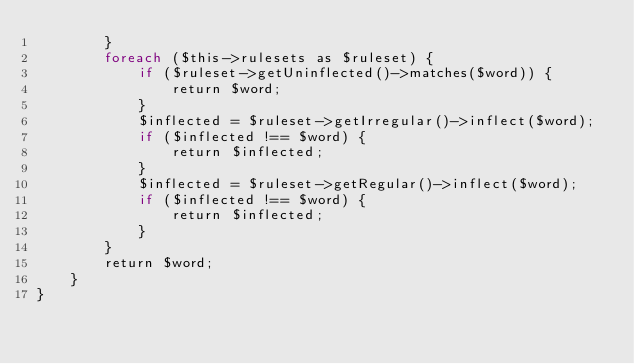Convert code to text. <code><loc_0><loc_0><loc_500><loc_500><_PHP_>        }
        foreach ($this->rulesets as $ruleset) {
            if ($ruleset->getUninflected()->matches($word)) {
                return $word;
            }
            $inflected = $ruleset->getIrregular()->inflect($word);
            if ($inflected !== $word) {
                return $inflected;
            }
            $inflected = $ruleset->getRegular()->inflect($word);
            if ($inflected !== $word) {
                return $inflected;
            }
        }
        return $word;
    }
}
</code> 